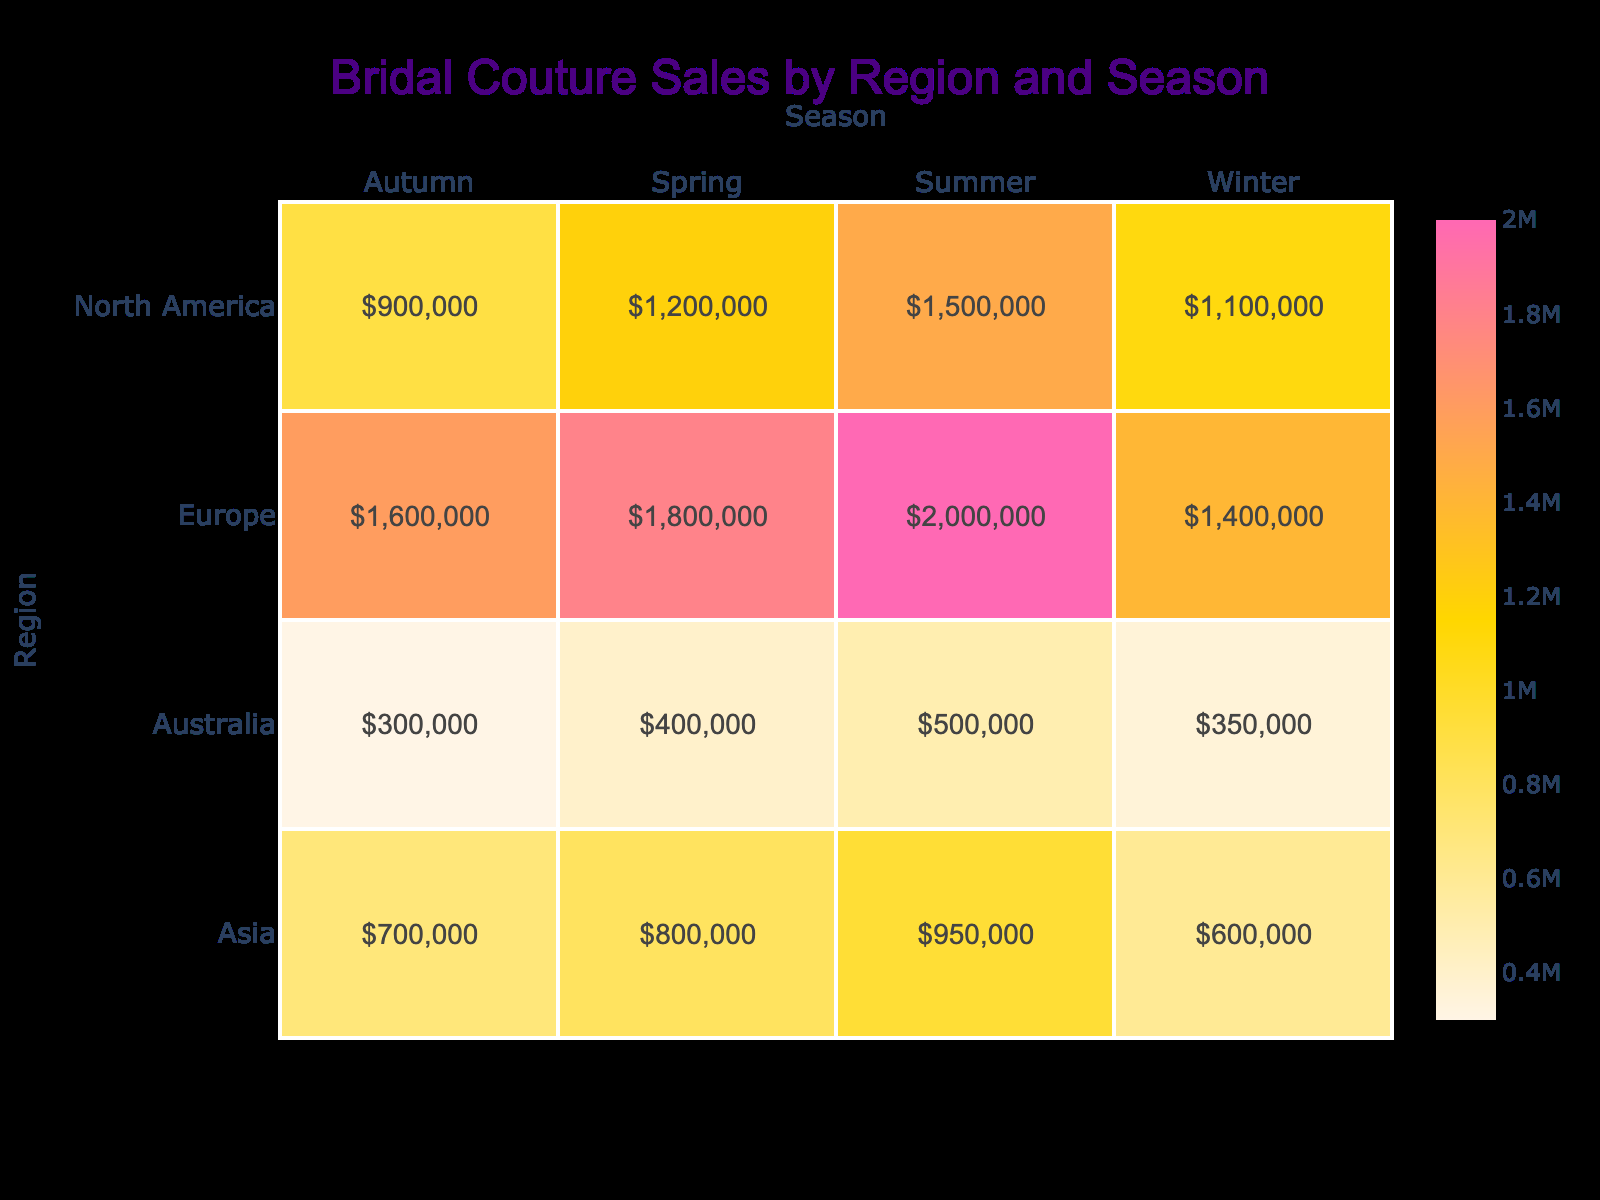What region had the highest bridal couture sales in Summer? Looking at the Summer column, North America shows sales of 1,500,000 USD, whereas Europe shows higher sales of 2,000,000 USD. Therefore, Europe is the region with the highest sales in Summer.
Answer: Europe What is the average dress price for the best-selling designer in Winter? In the Winter column, the best-selling designer is Berta Bridal with sales of 1,400,000 USD. The average dress price for Berta Bridal is 8,000 USD.
Answer: 8,000 USD Which region had the lowest bridal couture sales in Autumn? Autumn sales for each region show North America at 900,000 USD, Europe at 1,600,000 USD, Asia at 700,000 USD, and Australia at 300,000 USD. The lowest is 300,000 USD in Australia.
Answer: Australia What is the total amount of bridal couture sales across all regions in Spring? Adding Spring sales: North America (1,200,000) + Europe (1,800,000) + Asia (800,000) + Australia (400,000) gives a total of 4,200,000 USD.
Answer: 4,200,000 USD Does Asia show a higher number of sales in Summer compared to North America? In Summer, Asia has 190 sales while North America shows 250. Therefore, Asia does not have more sales than North America in Summer.
Answer: No What is the percentage increase in bridal couture sales from Spring to Summer in Europe? For Europe, Spring sales are 1,800,000 and Summer sales are 2,000,000. The increase is 2,000,000 - 1,800,000 = 200,000. The percentage increase is (200,000 / 1,800,000) * 100 = 11.11%.
Answer: 11.11% What is the total number of bridal couture sales across all regions in Winter? Summing the number of sales in Winter: North America (200) + Europe (175) + Asia (140) + Australia (110) results in a total of 625 sales.
Answer: 625 Which region experienced a decline in bridal couture sales from Spring to Autumn? In North America, sales declined from 1,200,000 in Spring to 900,000 in Autumn. Therefore, North America experienced a decline.
Answer: North America Is the top designer in Asia the same as in North America? In Asia, the top designer is Naeem Khan, while in North America, it is Monique Lhuillier. Therefore, the top designers are not the same.
Answer: No 